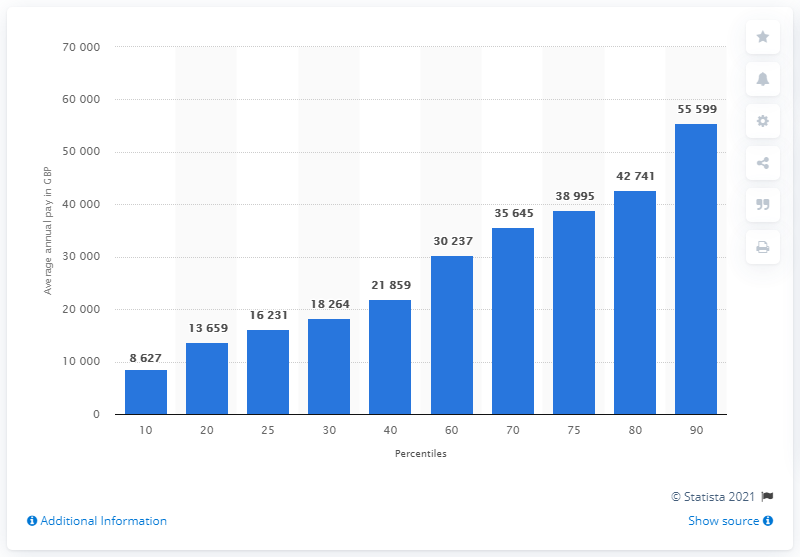Identify some key points in this picture. The average annual gross salary of the top ten percent of workers in the UK in 2020 was approximately 55,599 pounds. In 2020, a significant percentage of workers earned less than 8,600 pounds. 